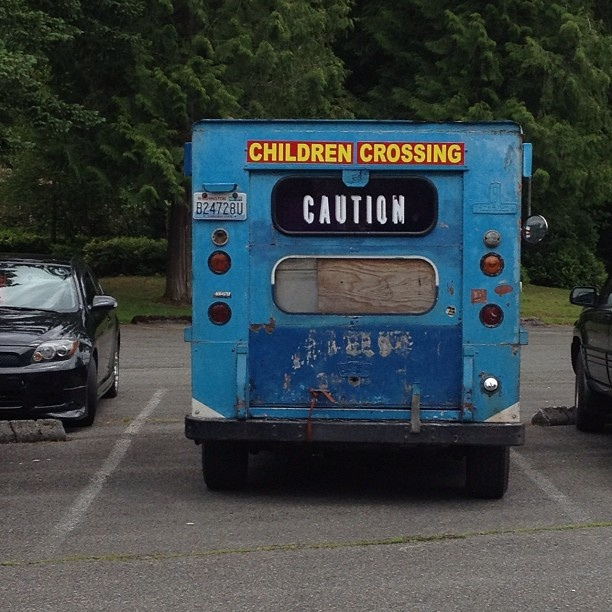Describe the objects in this image and their specific colors. I can see truck in black, teal, navy, and blue tones, car in black, gray, and darkgray tones, and car in black and gray tones in this image. 